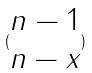Convert formula to latex. <formula><loc_0><loc_0><loc_500><loc_500>( \begin{matrix} n - 1 \\ n - x \end{matrix} )</formula> 